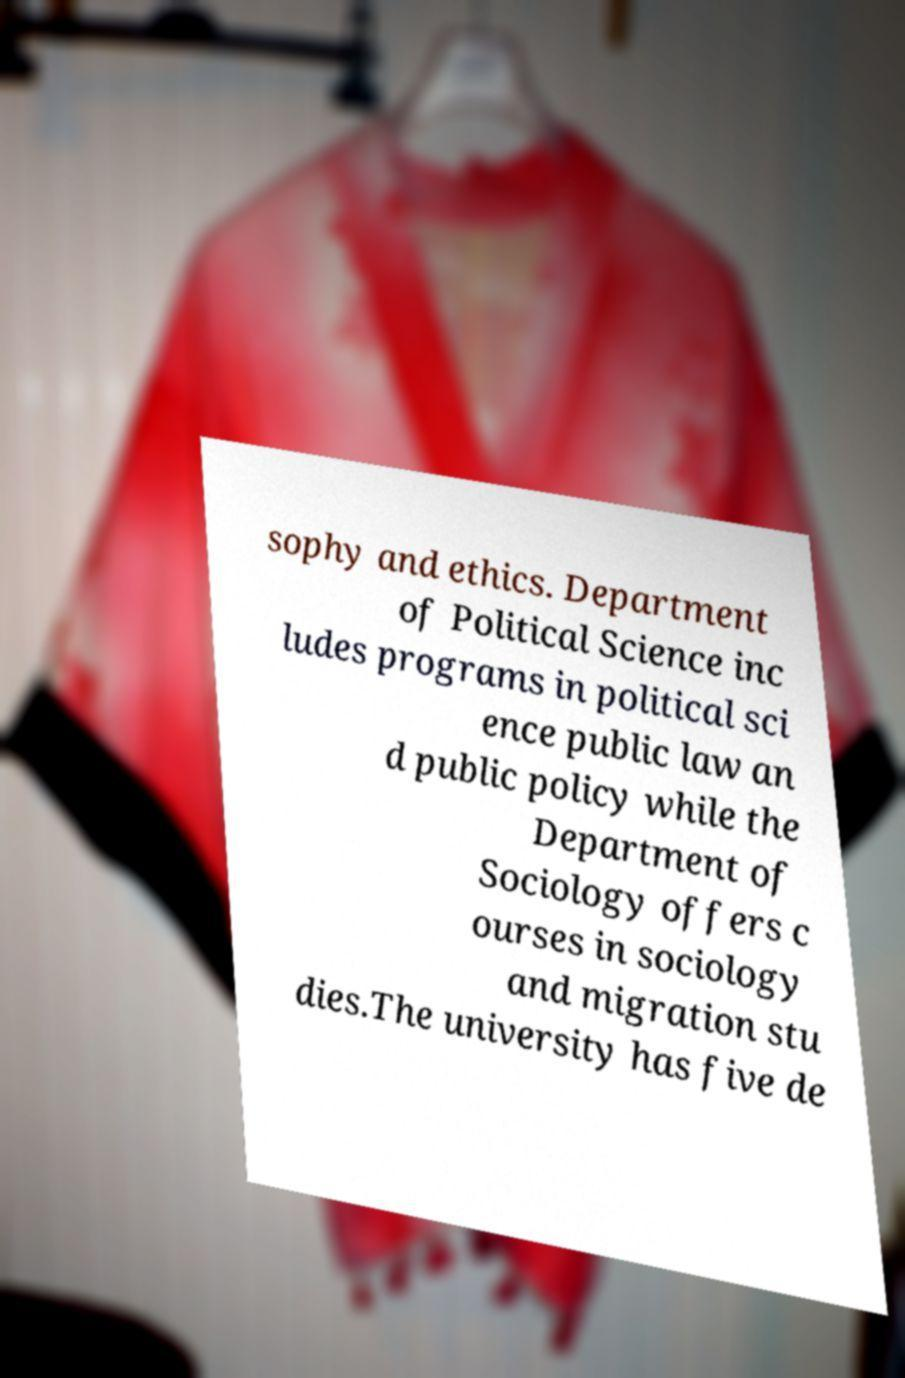For documentation purposes, I need the text within this image transcribed. Could you provide that? sophy and ethics. Department of Political Science inc ludes programs in political sci ence public law an d public policy while the Department of Sociology offers c ourses in sociology and migration stu dies.The university has five de 